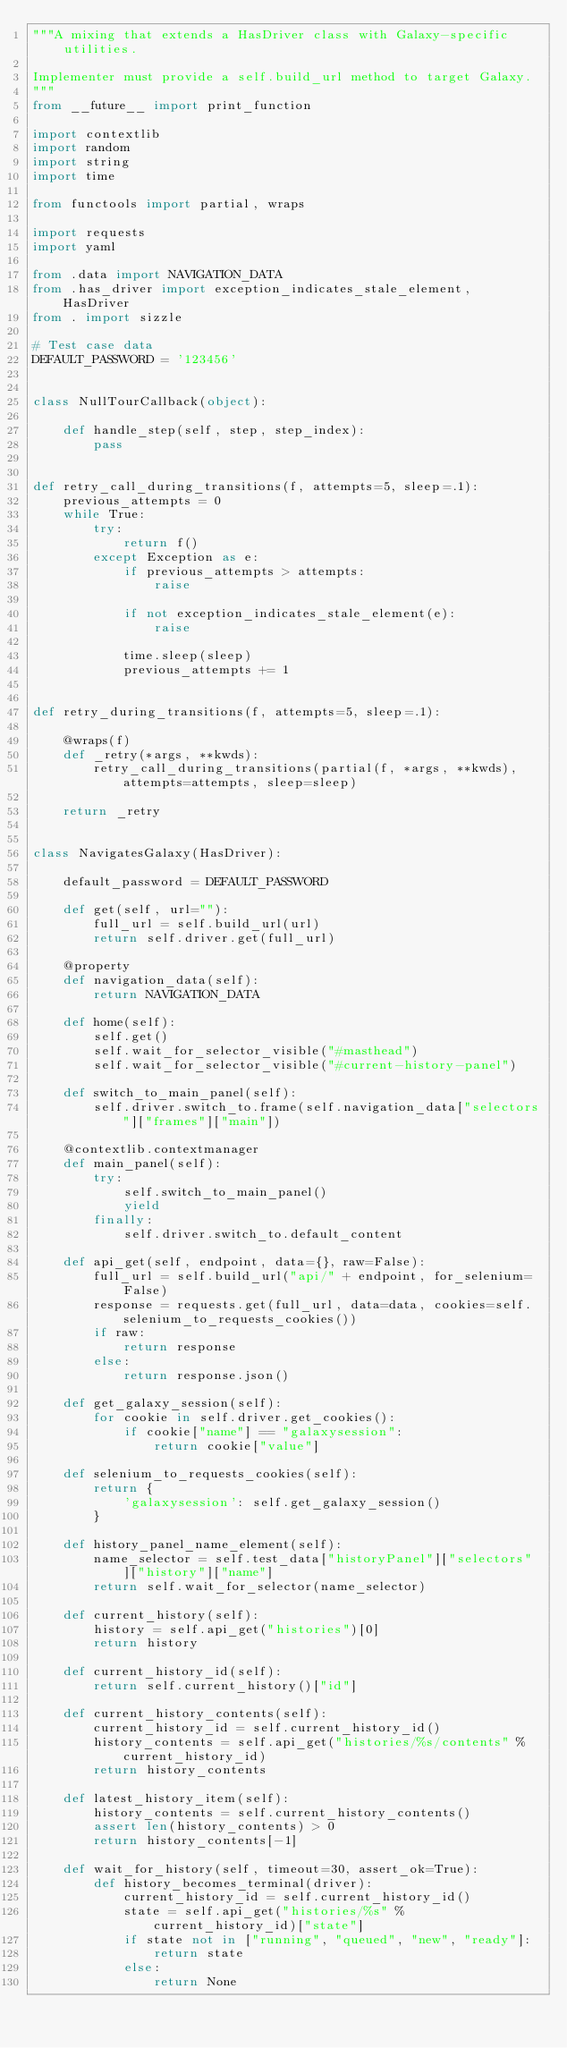<code> <loc_0><loc_0><loc_500><loc_500><_Python_>"""A mixing that extends a HasDriver class with Galaxy-specific utilities.

Implementer must provide a self.build_url method to target Galaxy.
"""
from __future__ import print_function

import contextlib
import random
import string
import time

from functools import partial, wraps

import requests
import yaml

from .data import NAVIGATION_DATA
from .has_driver import exception_indicates_stale_element, HasDriver
from . import sizzle

# Test case data
DEFAULT_PASSWORD = '123456'


class NullTourCallback(object):

    def handle_step(self, step, step_index):
        pass


def retry_call_during_transitions(f, attempts=5, sleep=.1):
    previous_attempts = 0
    while True:
        try:
            return f()
        except Exception as e:
            if previous_attempts > attempts:
                raise

            if not exception_indicates_stale_element(e):
                raise

            time.sleep(sleep)
            previous_attempts += 1


def retry_during_transitions(f, attempts=5, sleep=.1):

    @wraps(f)
    def _retry(*args, **kwds):
        retry_call_during_transitions(partial(f, *args, **kwds), attempts=attempts, sleep=sleep)

    return _retry


class NavigatesGalaxy(HasDriver):

    default_password = DEFAULT_PASSWORD

    def get(self, url=""):
        full_url = self.build_url(url)
        return self.driver.get(full_url)

    @property
    def navigation_data(self):
        return NAVIGATION_DATA

    def home(self):
        self.get()
        self.wait_for_selector_visible("#masthead")
        self.wait_for_selector_visible("#current-history-panel")

    def switch_to_main_panel(self):
        self.driver.switch_to.frame(self.navigation_data["selectors"]["frames"]["main"])

    @contextlib.contextmanager
    def main_panel(self):
        try:
            self.switch_to_main_panel()
            yield
        finally:
            self.driver.switch_to.default_content

    def api_get(self, endpoint, data={}, raw=False):
        full_url = self.build_url("api/" + endpoint, for_selenium=False)
        response = requests.get(full_url, data=data, cookies=self.selenium_to_requests_cookies())
        if raw:
            return response
        else:
            return response.json()

    def get_galaxy_session(self):
        for cookie in self.driver.get_cookies():
            if cookie["name"] == "galaxysession":
                return cookie["value"]

    def selenium_to_requests_cookies(self):
        return {
            'galaxysession': self.get_galaxy_session()
        }

    def history_panel_name_element(self):
        name_selector = self.test_data["historyPanel"]["selectors"]["history"]["name"]
        return self.wait_for_selector(name_selector)

    def current_history(self):
        history = self.api_get("histories")[0]
        return history

    def current_history_id(self):
        return self.current_history()["id"]

    def current_history_contents(self):
        current_history_id = self.current_history_id()
        history_contents = self.api_get("histories/%s/contents" % current_history_id)
        return history_contents

    def latest_history_item(self):
        history_contents = self.current_history_contents()
        assert len(history_contents) > 0
        return history_contents[-1]

    def wait_for_history(self, timeout=30, assert_ok=True):
        def history_becomes_terminal(driver):
            current_history_id = self.current_history_id()
            state = self.api_get("histories/%s" % current_history_id)["state"]
            if state not in ["running", "queued", "new", "ready"]:
                return state
            else:
                return None
</code> 